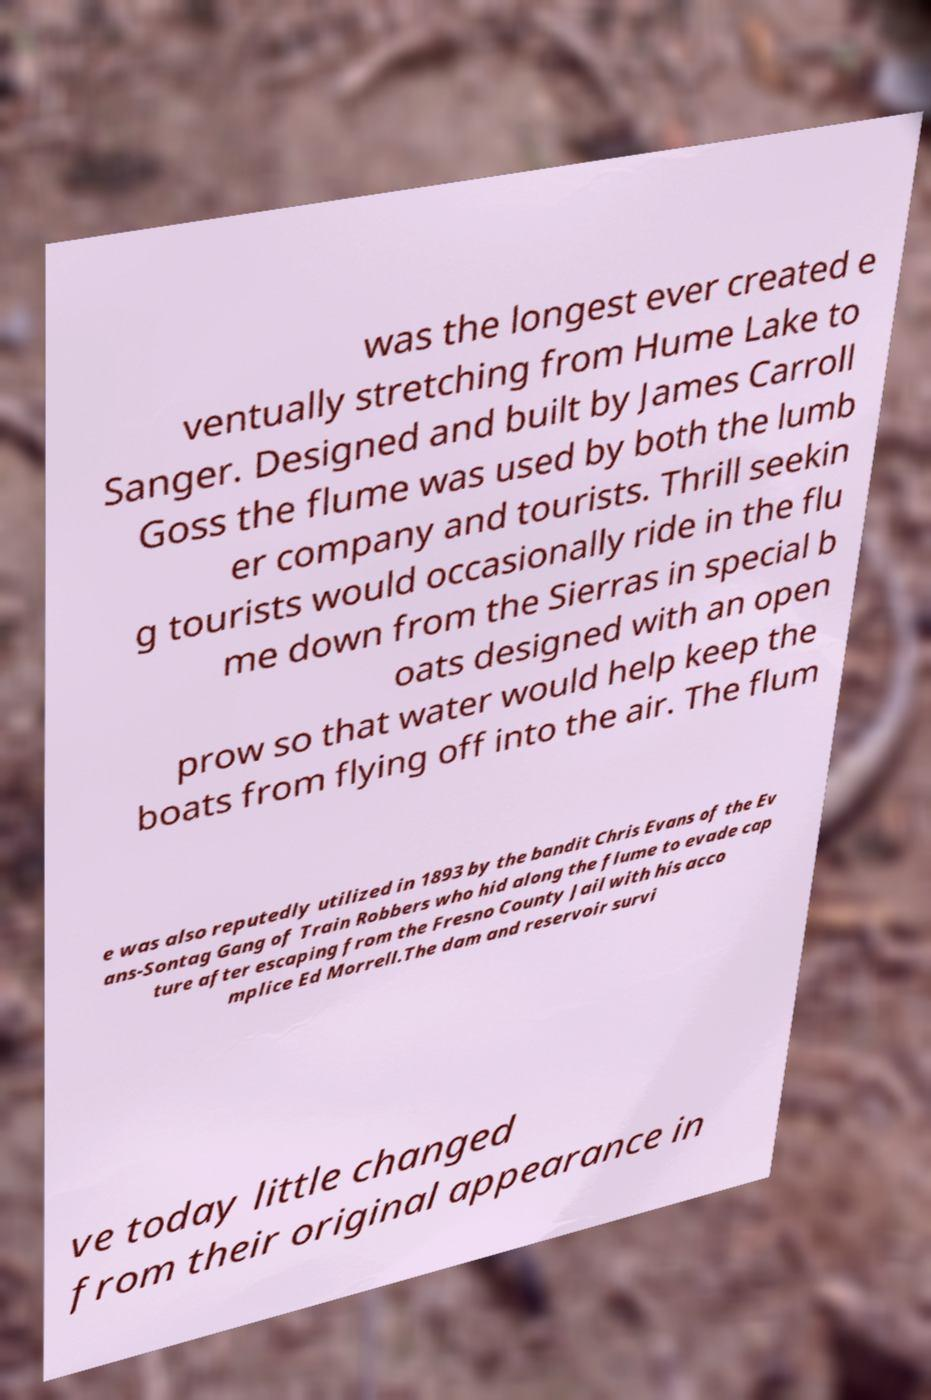Can you accurately transcribe the text from the provided image for me? was the longest ever created e ventually stretching from Hume Lake to Sanger. Designed and built by James Carroll Goss the flume was used by both the lumb er company and tourists. Thrill seekin g tourists would occasionally ride in the flu me down from the Sierras in special b oats designed with an open prow so that water would help keep the boats from flying off into the air. The flum e was also reputedly utilized in 1893 by the bandit Chris Evans of the Ev ans-Sontag Gang of Train Robbers who hid along the flume to evade cap ture after escaping from the Fresno County Jail with his acco mplice Ed Morrell.The dam and reservoir survi ve today little changed from their original appearance in 